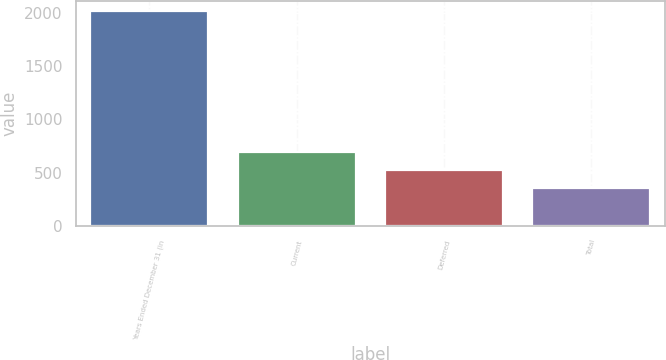Convert chart. <chart><loc_0><loc_0><loc_500><loc_500><bar_chart><fcel>Years Ended December 31 (in<fcel>Current<fcel>Deferred<fcel>Total<nl><fcel>2013<fcel>690.6<fcel>525.3<fcel>360<nl></chart> 